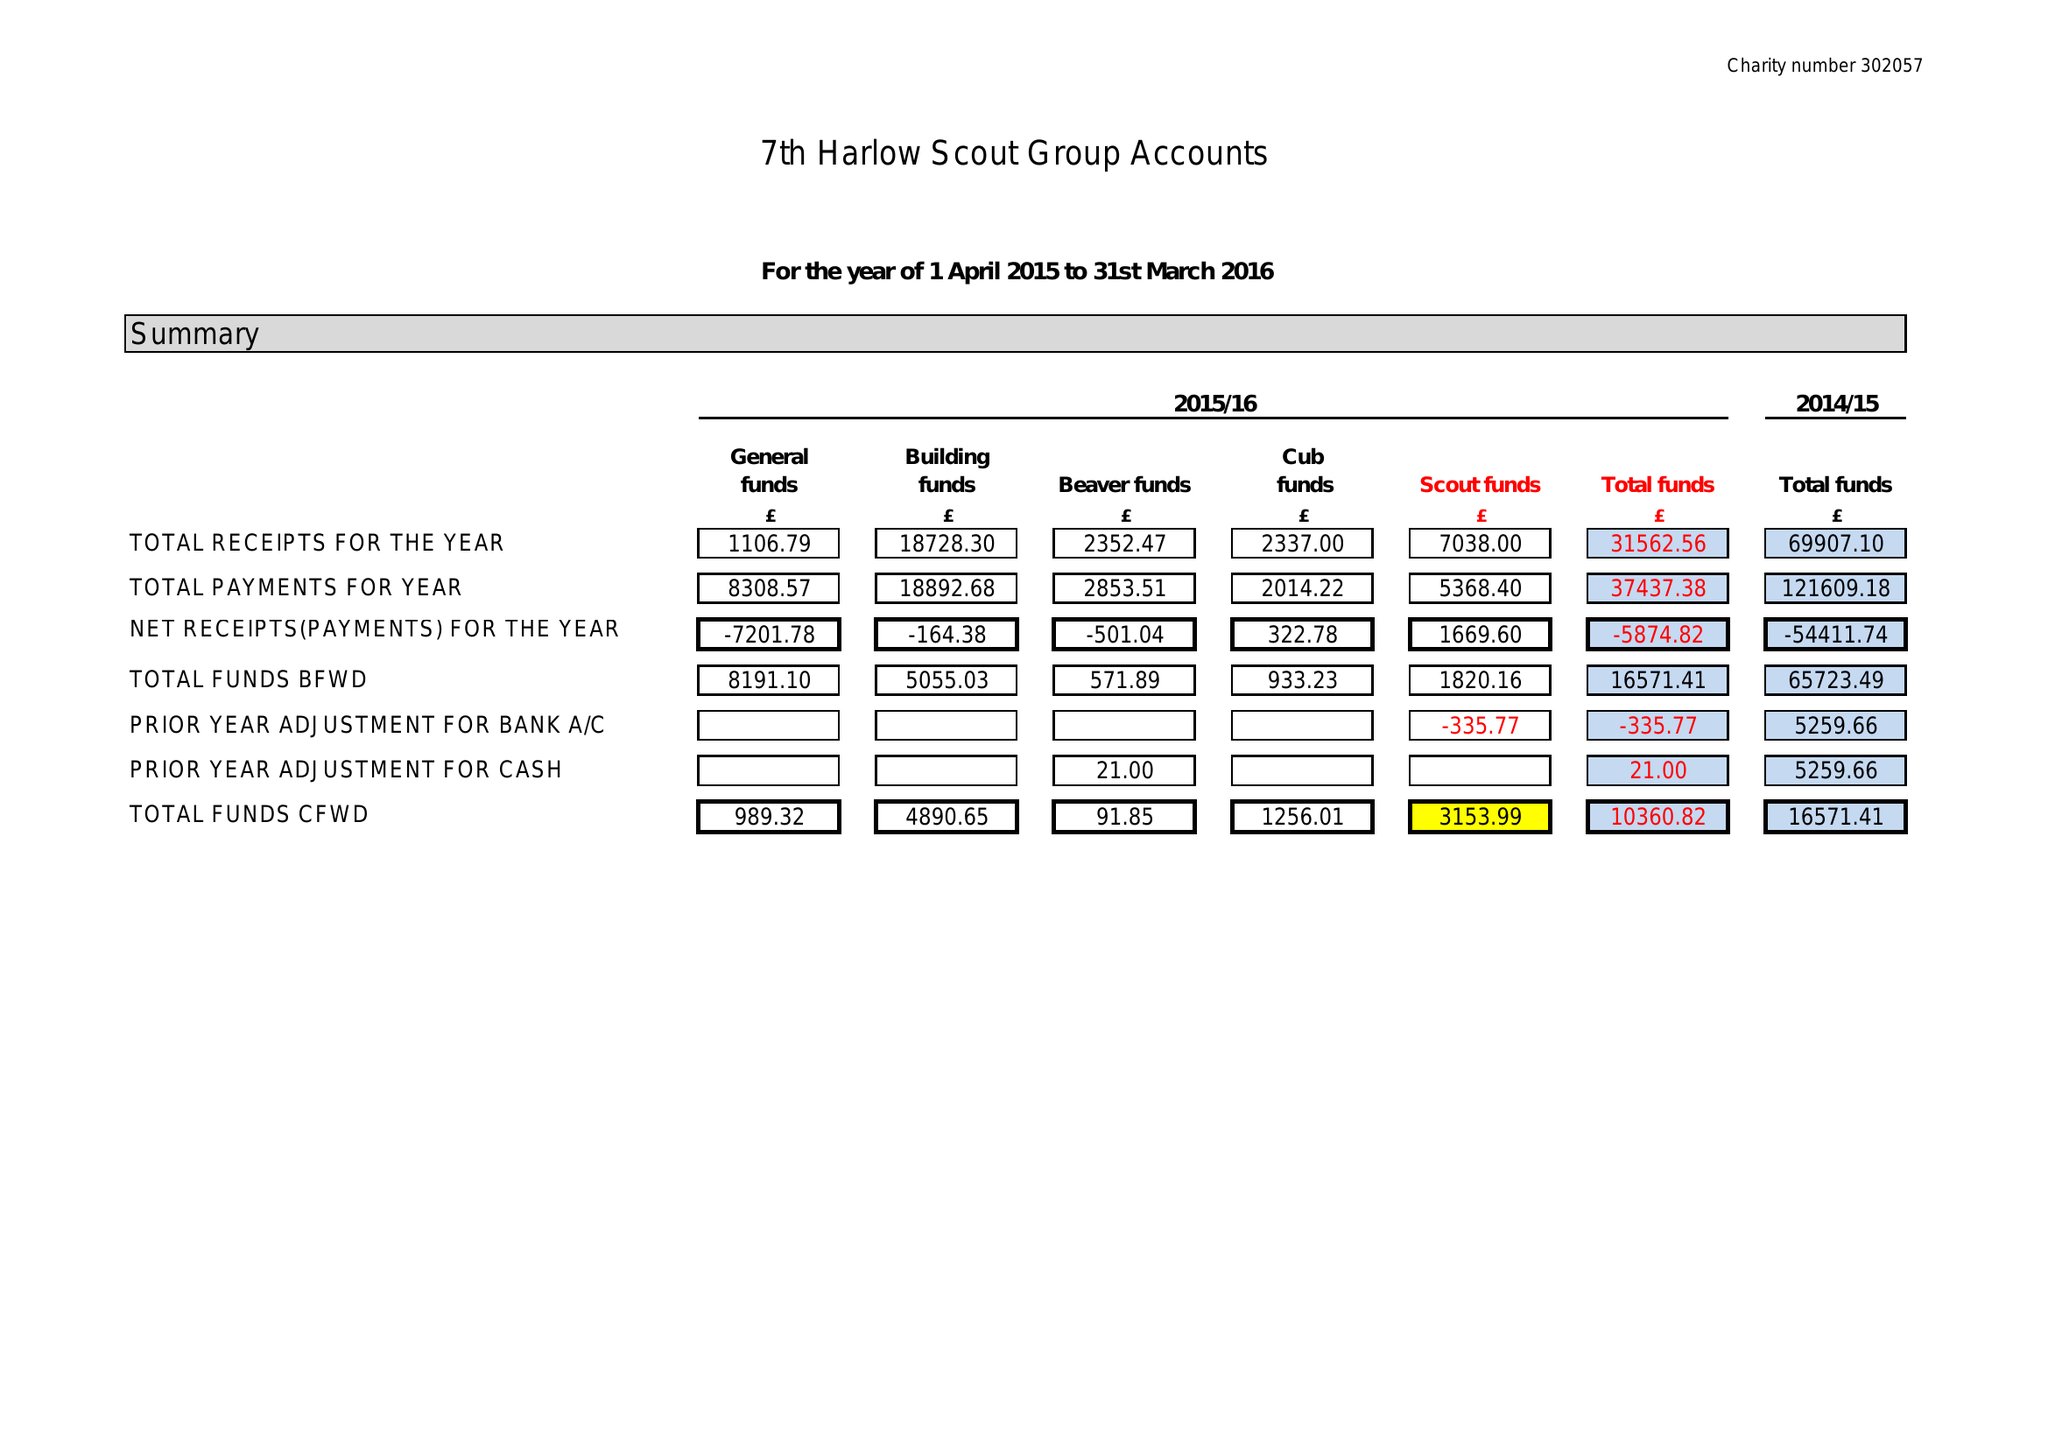What is the value for the address__street_line?
Answer the question using a single word or phrase. 50 RAM GORSE 